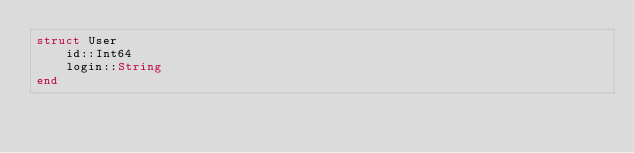Convert code to text. <code><loc_0><loc_0><loc_500><loc_500><_Julia_>struct User
    id::Int64
    login::String
end
</code> 